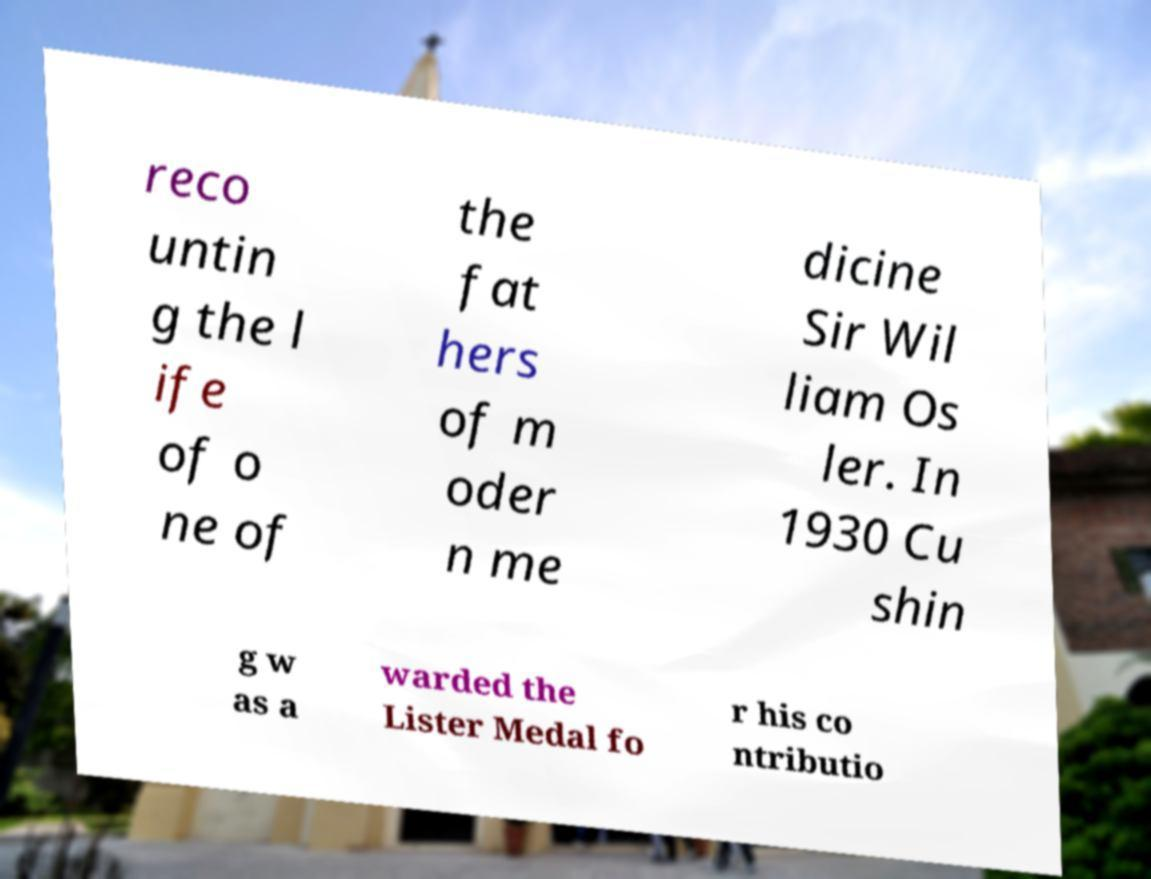Please read and relay the text visible in this image. What does it say? reco untin g the l ife of o ne of the fat hers of m oder n me dicine Sir Wil liam Os ler. In 1930 Cu shin g w as a warded the Lister Medal fo r his co ntributio 